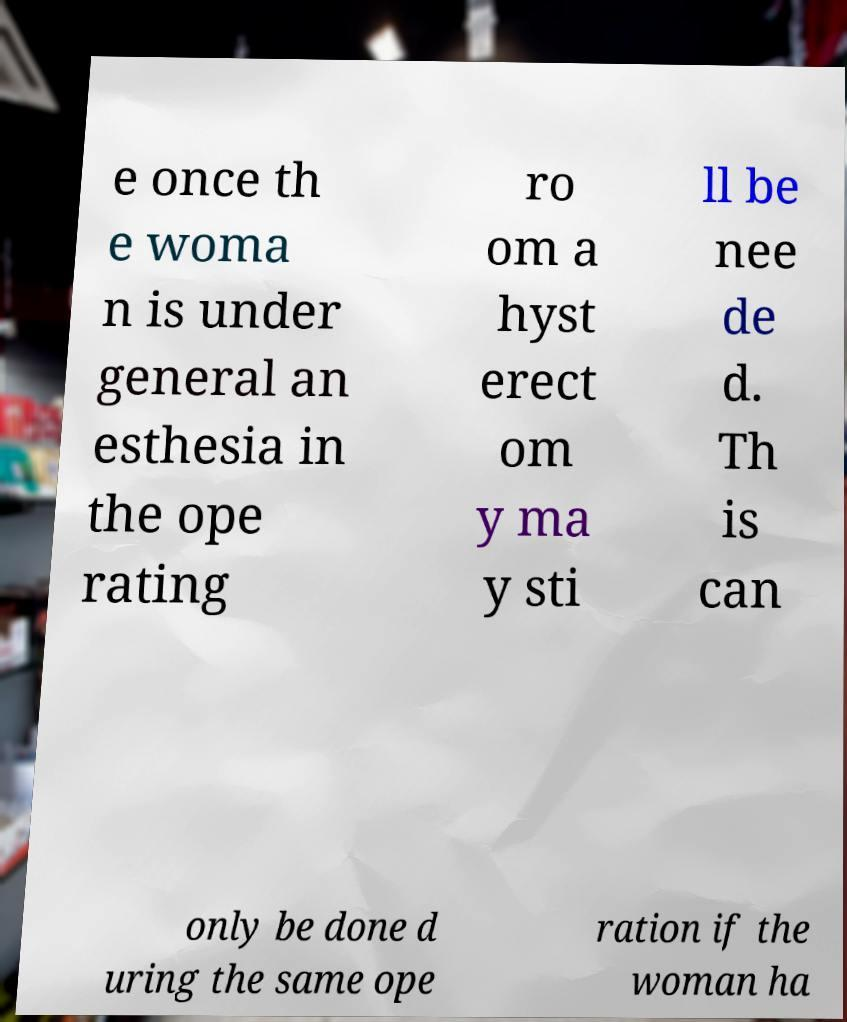Could you assist in decoding the text presented in this image and type it out clearly? e once th e woma n is under general an esthesia in the ope rating ro om a hyst erect om y ma y sti ll be nee de d. Th is can only be done d uring the same ope ration if the woman ha 